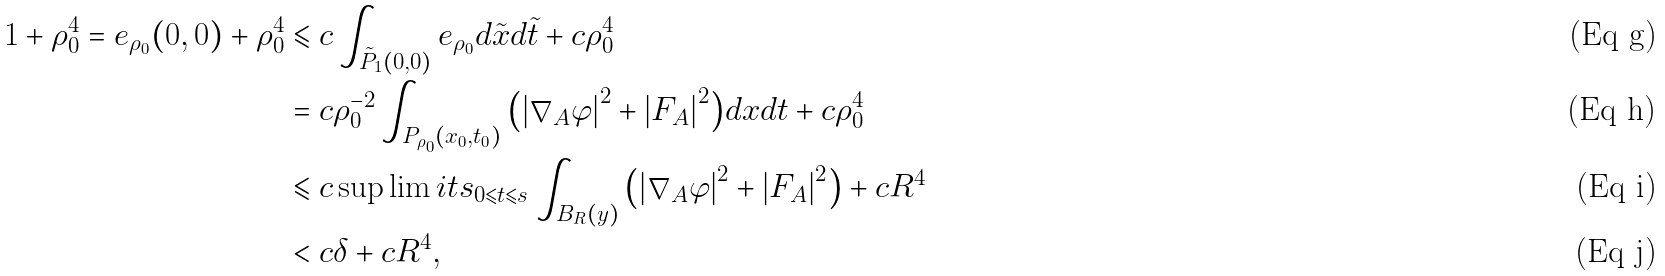<formula> <loc_0><loc_0><loc_500><loc_500>1 + \rho _ { 0 } ^ { 4 } = e _ { \rho _ { 0 } } ( 0 , 0 ) + \rho _ { 0 } ^ { 4 } & \leqslant c \int _ { \tilde { P } _ { 1 } ( 0 , 0 ) } { e _ { \rho _ { 0 } } d \tilde { x } d \tilde { t } } + c \rho _ { 0 } ^ { 4 } \\ & = c \rho _ { 0 } ^ { - 2 } \int _ { P _ { \rho _ { 0 } } ( x _ { 0 } , t _ { 0 } ) } { \left ( { \left | { \nabla _ { A } \varphi } \right | ^ { 2 } + \left | { F _ { A } } \right | ^ { 2 } } \right ) } d x d t + c \rho _ { 0 } ^ { 4 } \\ & \leqslant c \sup \lim i t s _ { 0 \leqslant t \leqslant s } \int _ { B _ { R } ( y ) } { \left ( { \left | { \nabla _ { A } \varphi } \right | ^ { 2 } + \left | { F _ { A } } \right | ^ { 2 } } \right ) } + c R ^ { 4 } \\ & < c \delta + c R ^ { 4 } ,</formula> 